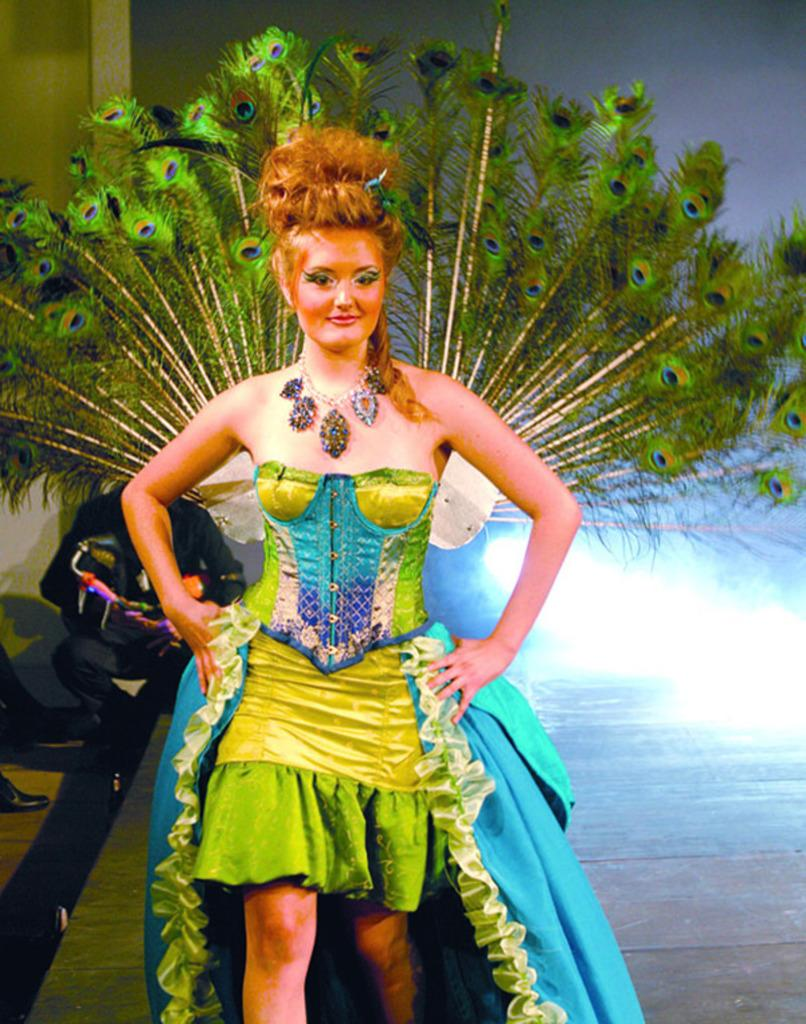What is the main subject in the center of the image? There is a lady dressed in a costume in the center of the image. Can you describe the setting of the image? There is a man in the background of the image. What can be seen on the right side of the image? There is a light on the right side of the image. What type of apparel is the visitor wearing in the image? There is no visitor present in the image, and therefore no apparel can be described for them. 